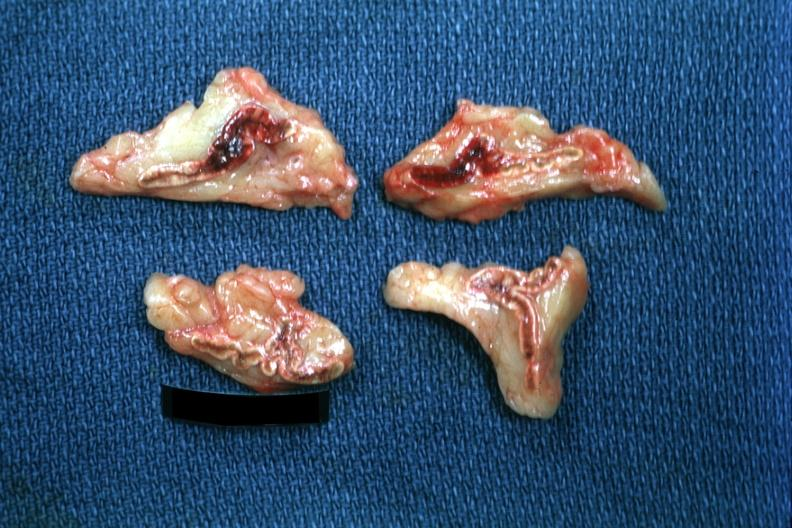what does this image show?
Answer the question using a single word or phrase. Cortical and medullary hemorrhage not extensive but clearly evident case of pneumococcal meningitis lesion probably due to septic shock 